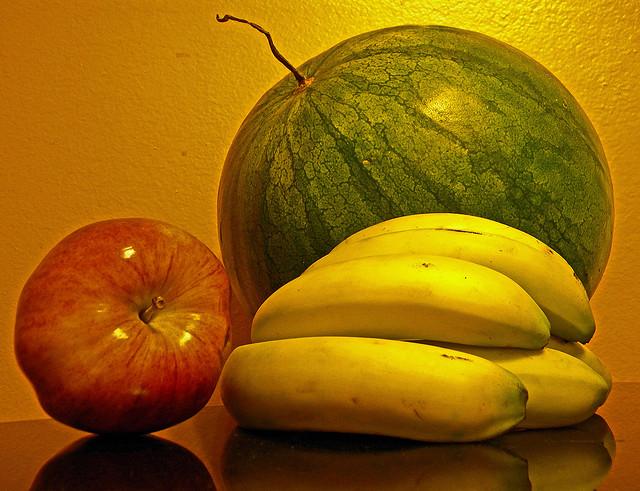What is the biggest fruit?
Write a very short answer. Watermelon. Would a vegetarian eat all these foods?
Short answer required. Yes. What fruit is green?
Answer briefly. Watermelon. 